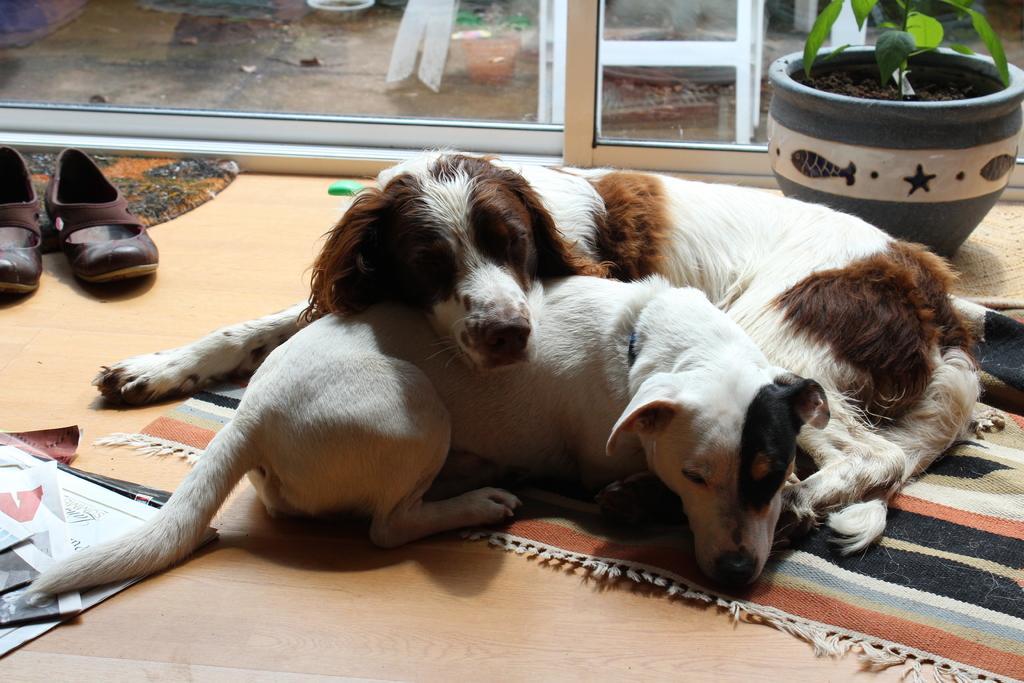Can you describe this image briefly? In this image we can see the two dogs on the mat. Image also consists of a flower pot, paper and a pair of shoes and a door mat on the floor. In the background we can see a glass window. 